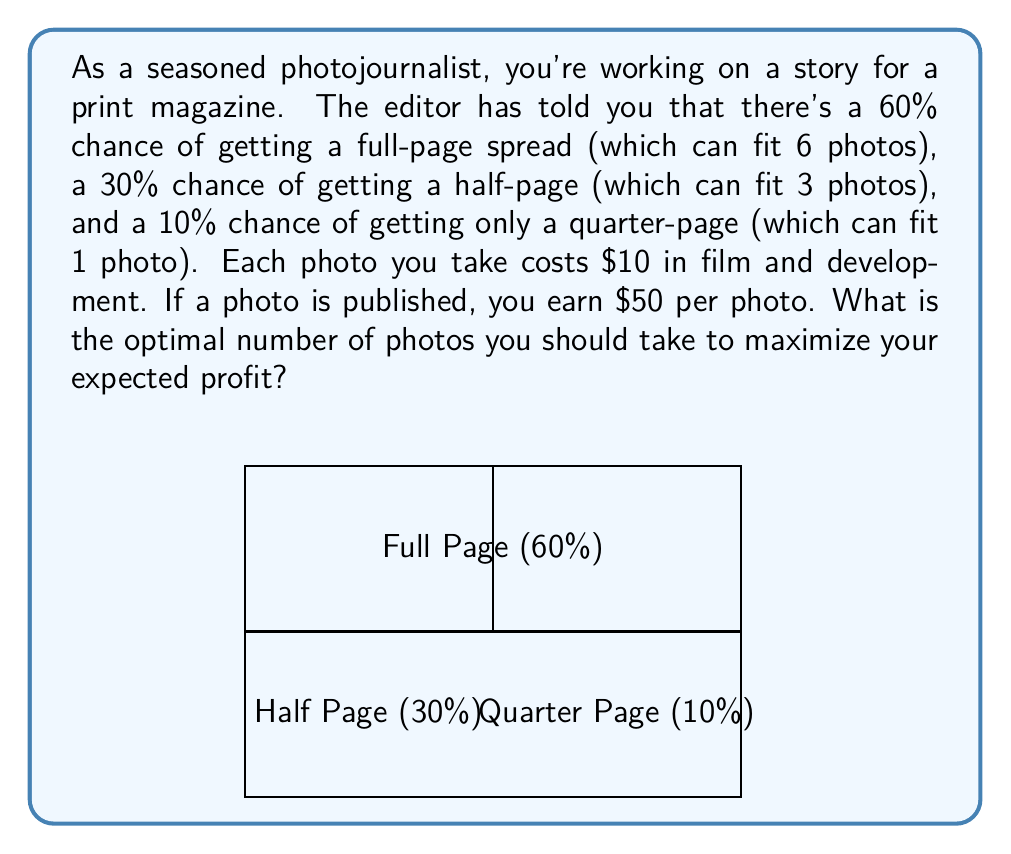What is the answer to this math problem? Let's approach this step-by-step:

1) First, we need to calculate the expected number of photos that will be published:

   $E(\text{photos published}) = 6 \cdot 0.60 + 3 \cdot 0.30 + 1 \cdot 0.10 = 4.5$

2) Now, let's define $n$ as the number of photos taken. The expected profit function will be:

   $E(\text{profit}) = 50 \cdot \min(n, 4.5) - 10n$

   This is because we expect to publish 4.5 photos on average, but we can't publish more photos than we take.

3) To find the maximum of this function, we need to consider two cases:

   Case 1: $n \leq 4.5$
   In this case, $E(\text{profit}) = 50n - 10n = 40n$
   This is increasing with $n$, so the optimal $n$ in this case is 4.

   Case 2: $n > 4.5$
   In this case, $E(\text{profit}) = 50 \cdot 4.5 - 10n = 225 - 10n$
   This is decreasing with $n$, so the optimal $n$ in this case is 5.

4) Comparing the two cases:
   For $n = 4$: $E(\text{profit}) = 40 \cdot 4 = 160$
   For $n = 5$: $E(\text{profit}) = 50 \cdot 4.5 - 10 \cdot 5 = 175$

5) Therefore, the optimal number of photos to take is 5, which gives the highest expected profit of $175.
Answer: 5 photos 